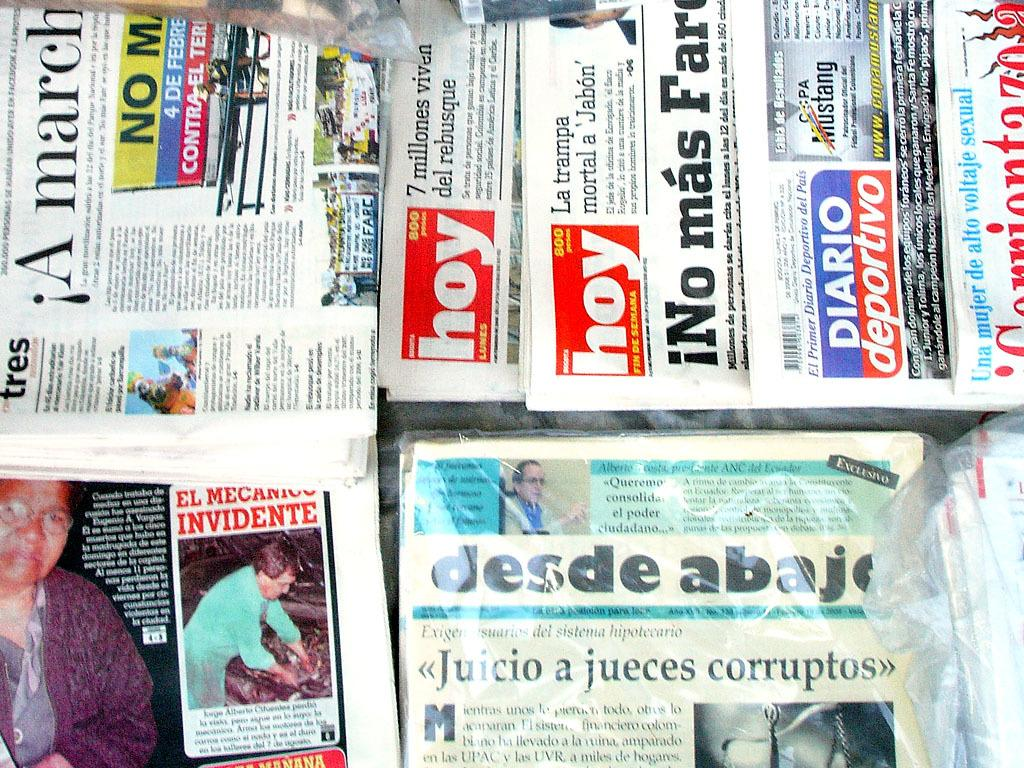<image>
Summarize the visual content of the image. A group of newspapers are laid on top of each other with some of them titled hoy. 